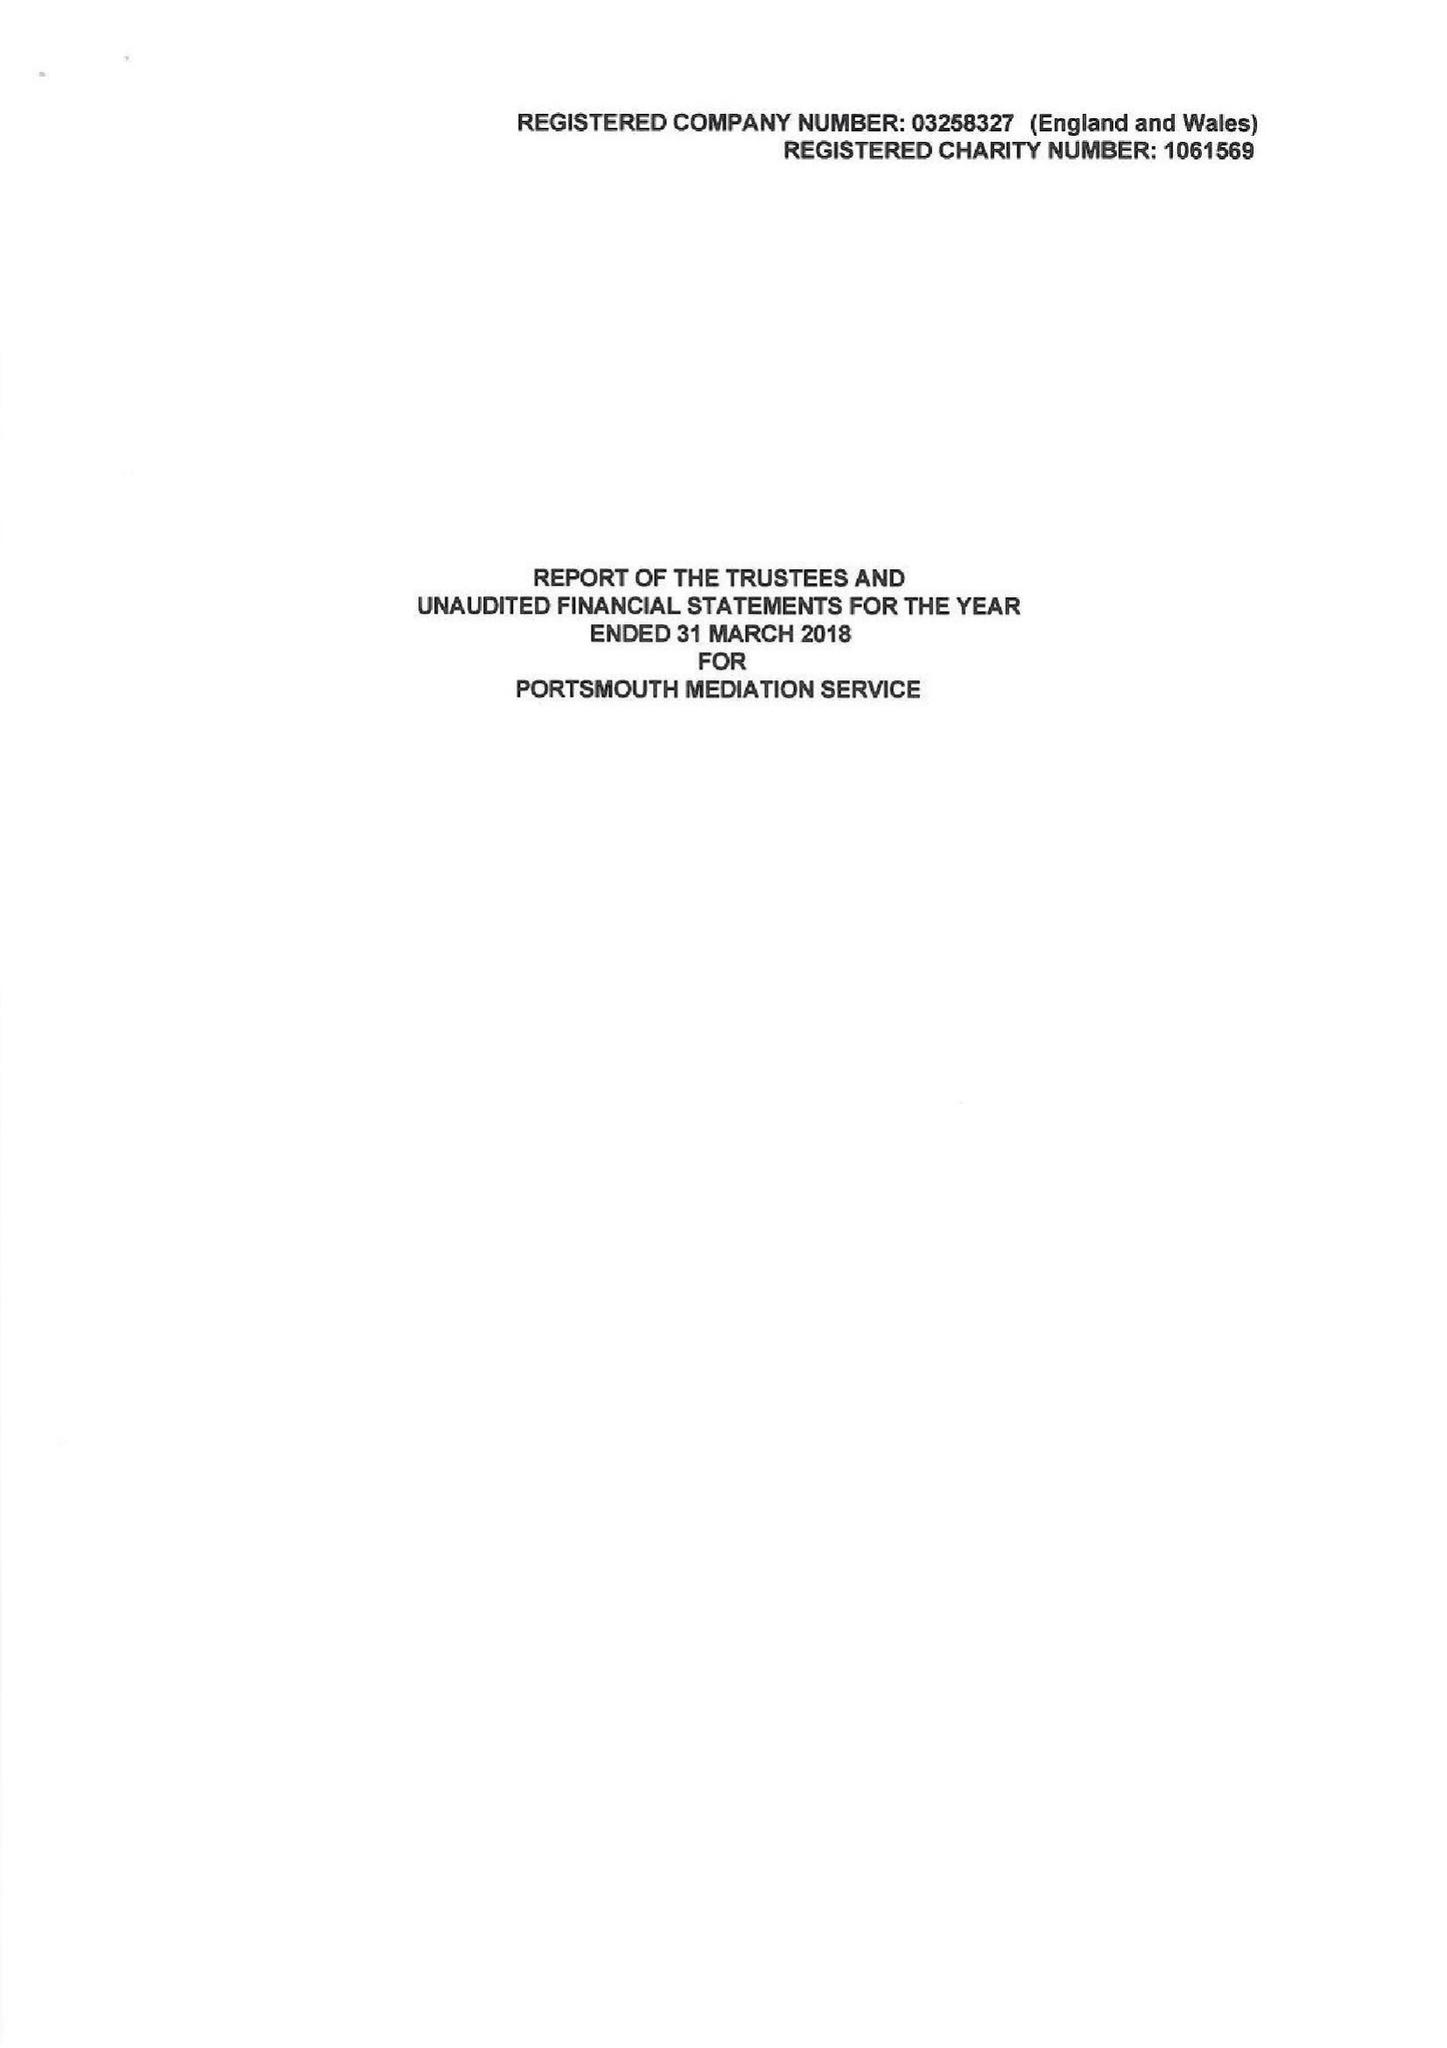What is the value for the address__postcode?
Answer the question using a single word or phrase. PO1 1NP 